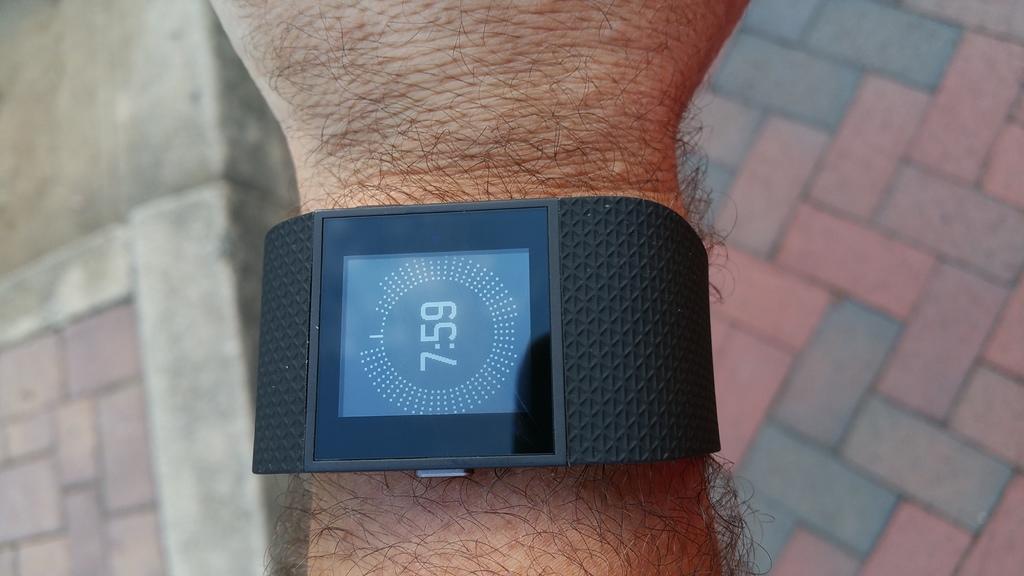What time is this?
Offer a very short reply. 7:59. 